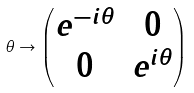<formula> <loc_0><loc_0><loc_500><loc_500>\theta \rightarrow \begin{pmatrix} e ^ { - i \theta } & 0 \\ 0 & e ^ { i \theta } \end{pmatrix}</formula> 